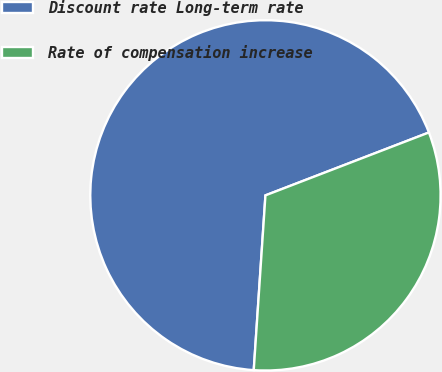<chart> <loc_0><loc_0><loc_500><loc_500><pie_chart><fcel>Discount rate Long-term rate<fcel>Rate of compensation increase<nl><fcel>68.09%<fcel>31.91%<nl></chart> 